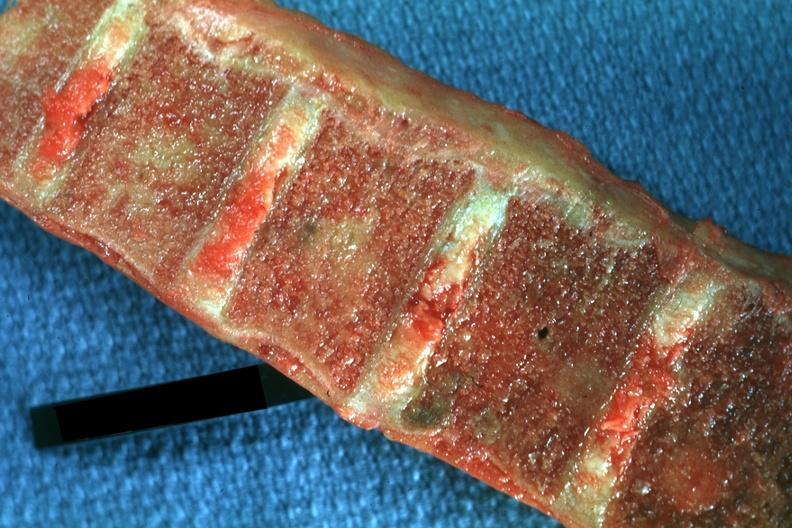what is present?
Answer the question using a single word or phrase. Joints 